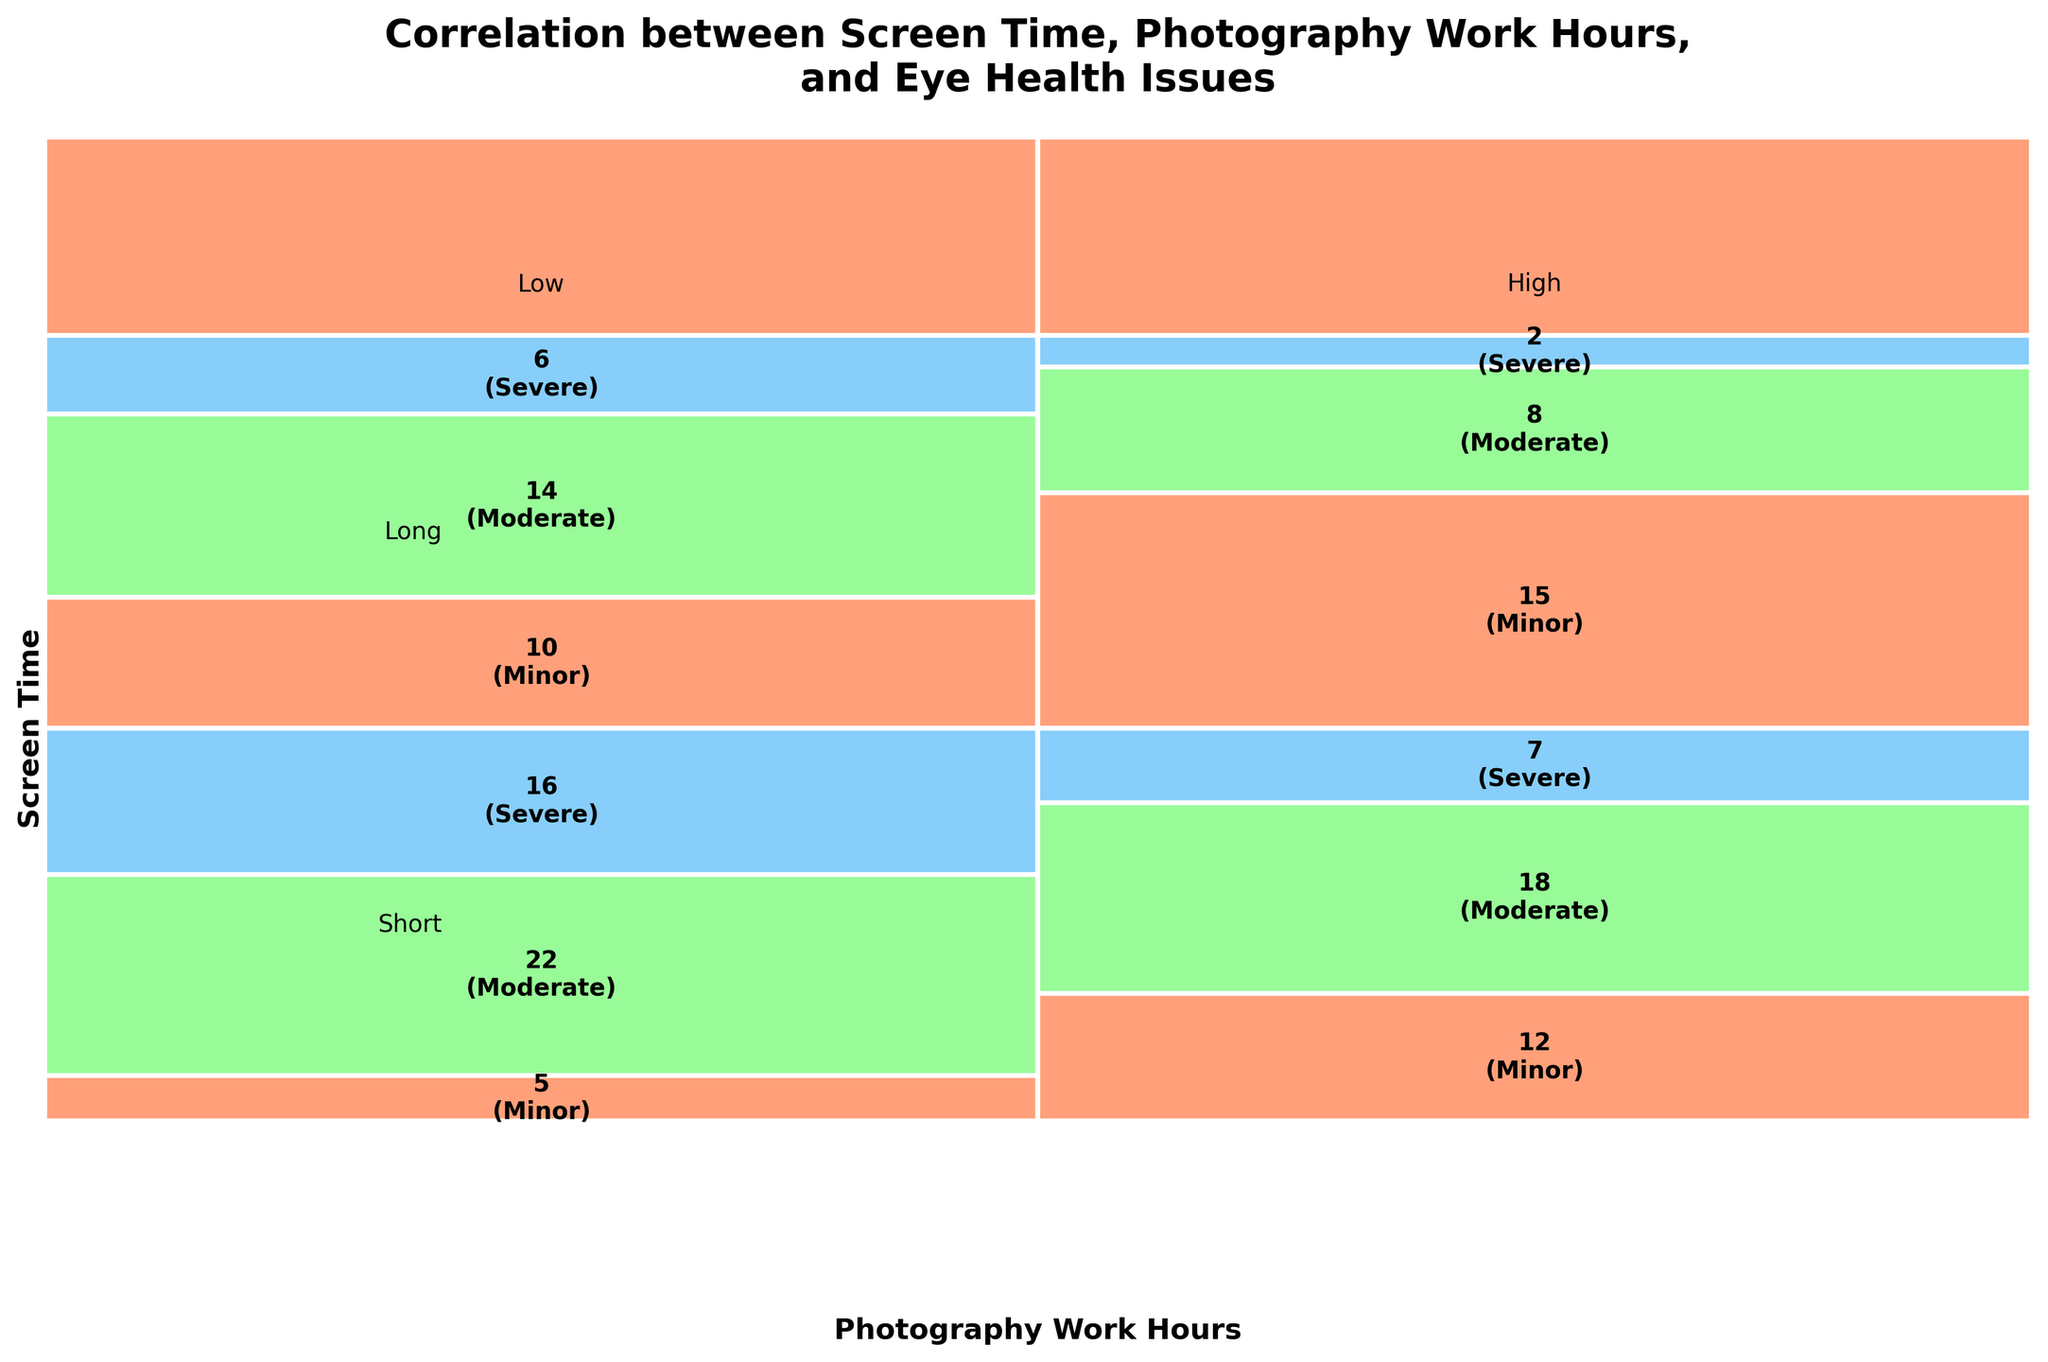How many categories are reported in the legend for eye health issues? The legend shows color codes for three categories of eye health issues: Minor, Moderate, and Severe. By looking at the bar sections and the corresponding color codes, we can count the categories.
Answer: Three categories Which combination of screen time and photography work hours has the highest count of severe eye health issues? By looking at the sizes of the bar sections labeled "Severe" (specifically looking for the sections with the color corresponding to Severe) for each combination, we can see that the "High" screen time and "Long" photography work hours combination has the largest segment for Severe eye health issues.
Answer: High screen time and Long work hours Which combination of screen time and photography work hours has the lowest total count of reported eye health issues? Summing the counts of Minor, Moderate, and Severe issues for each combination, we can see that "High" screen time combined with "Long" photography work hours has the lowest total count.
Answer: High screen time and Short work hours What is the total count of minor eye health issues? By summing up all the sections related to Minor eye health issues across all combinations: 15 (Low, Short) + 12 (Low, Long) + 10 (High, Short) + 5 (High, Long), we get a total of 42.
Answer: 42 How many more cases of moderate eye health issues are reported for high screen time compared to low screen time? Summing the counts for Moderate eye issues for high screen time (Short: 14 and Long: 22) and low screen time (Short: 8 and Long: 18), we get 36 for high screen time and 26 for low screen time. The difference is 36 - 26 = 10.
Answer: 10 Which screen time category has a higher total count of eye health issues? Summing across all work hours categories for each type: 
For Low screen time: Minor (15+12) + Moderate (8+18) + Severe (2+7) = 62. 
For High screen time: Minor (10+5) + Moderate (14+22) + Severe (6+16) = 73. 
High screen time has a higher count of eye health issues.
Answer: High screen time What is the most commonly reported level of eye health issues for those with long photography work hours? By comparing the counts of Minor, Moderate, and Severe eye health issues for the "Long" photography work hours category, we see that Moderate has the highest count (Low: 18, High: 22).
Answer: Moderate Is there any category which does not have any reported severe eye health issues? By looking at the counts for the Severe category across all combinations, we observe that every combination has at least some cases, hence there is no combination without any reported severe eye health issues.
Answer: No 